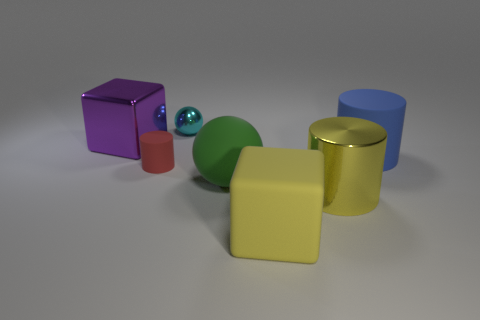There is a yellow thing that is the same shape as the purple thing; what material is it?
Keep it short and to the point. Rubber. Is there anything else that has the same material as the green object?
Your response must be concise. Yes. There is a large object that is both in front of the small red thing and behind the yellow cylinder; what is it made of?
Ensure brevity in your answer.  Rubber. How many other large objects are the same shape as the green matte object?
Your response must be concise. 0. What is the color of the large cylinder in front of the sphere that is in front of the blue rubber cylinder?
Ensure brevity in your answer.  Yellow. Is the number of large green spheres in front of the big blue rubber cylinder the same as the number of big shiny objects?
Your response must be concise. No. Is there another metallic cylinder that has the same size as the yellow cylinder?
Keep it short and to the point. No. Does the cyan ball have the same size as the cylinder left of the metal cylinder?
Make the answer very short. Yes. Is the number of large objects in front of the big green matte object the same as the number of yellow shiny cylinders that are behind the purple object?
Make the answer very short. No. What is the shape of the large matte thing that is the same color as the large metal cylinder?
Your answer should be compact. Cube. 